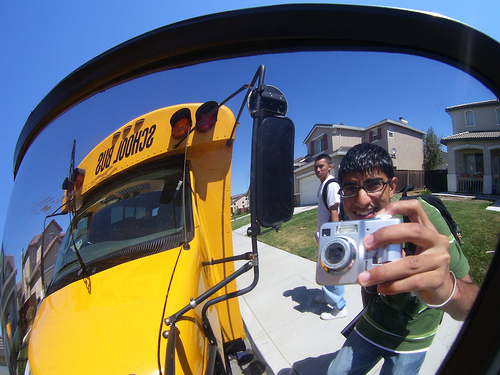Describe the relationship between the two boys in the image. The image shows two boys, where one in the foreground is smiling and holding a silver camera, seeming to document their fun moment. The boy in the background appears to be walking towards the camera, possibly sharing a friendly conversation with the boy in the foreground. Their body language and expressions suggest that they are friends or classmates enjoying a lively day outside. 